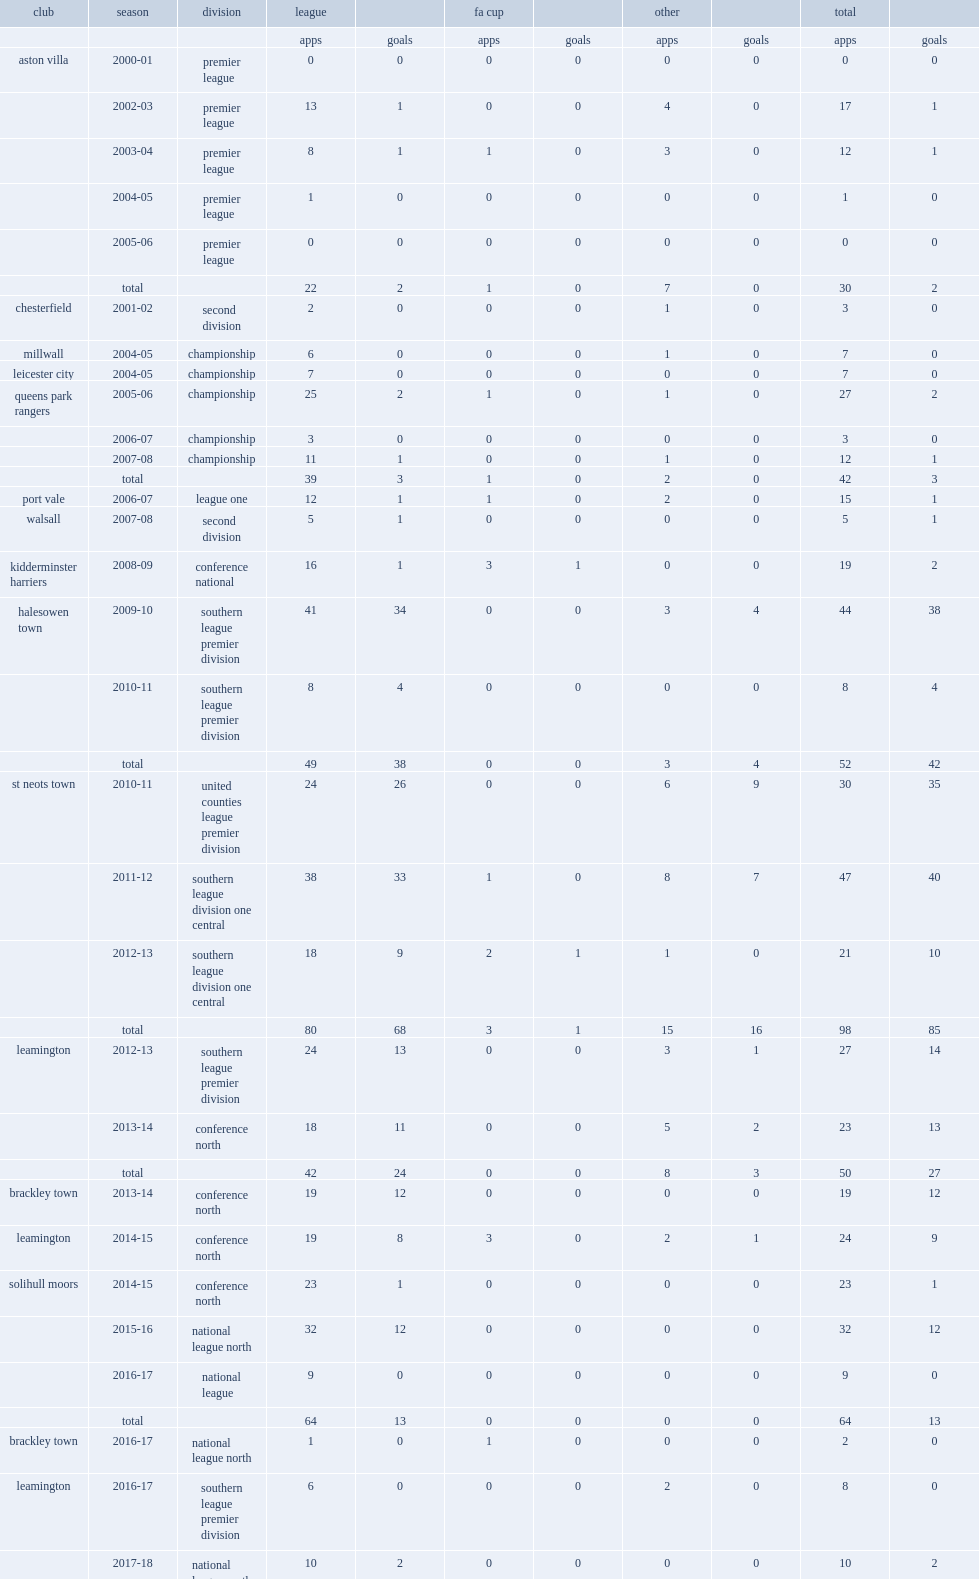Which club did stefan moore join in the united counties league premier division in 2010-11? St neots town. 